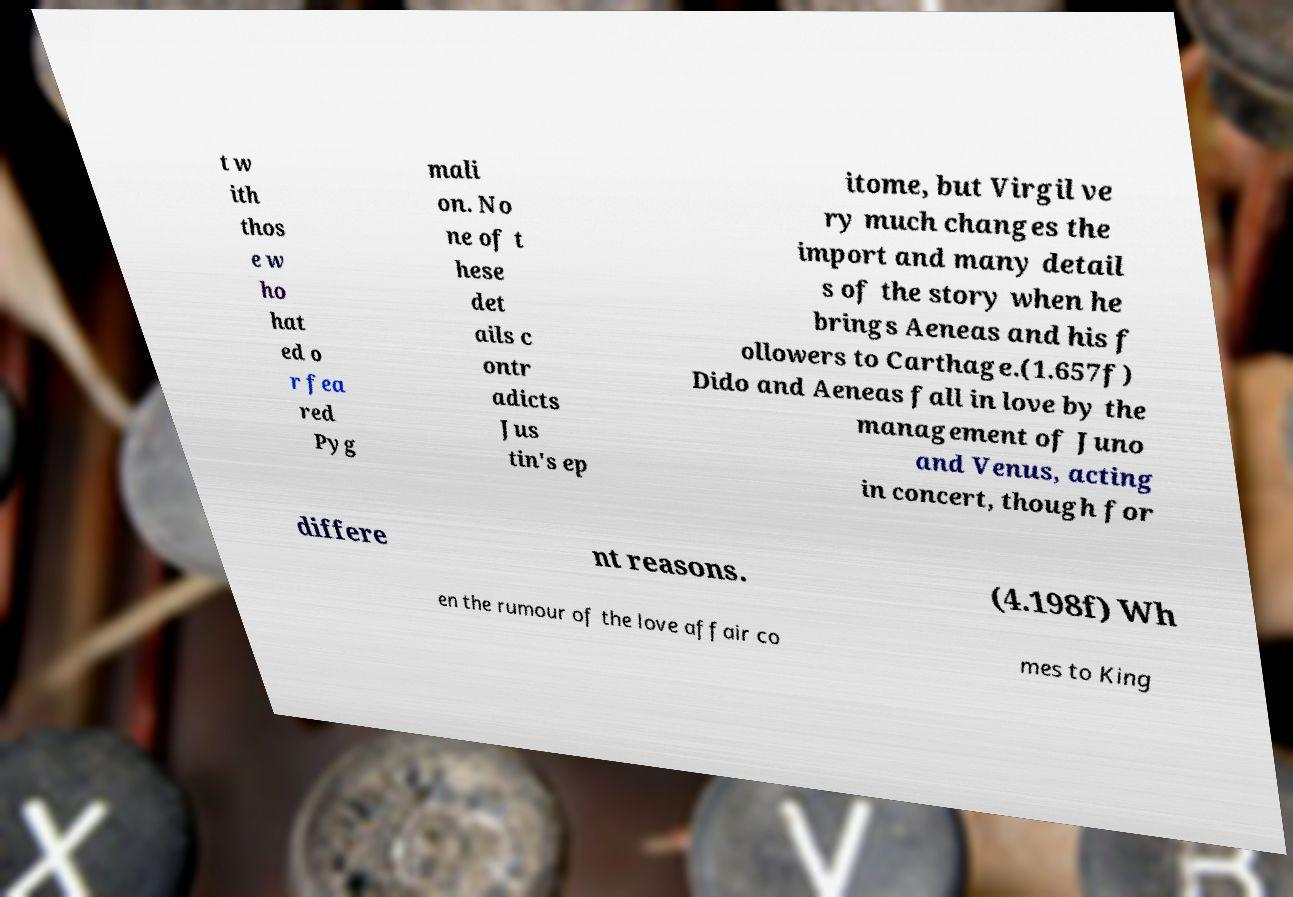Please identify and transcribe the text found in this image. t w ith thos e w ho hat ed o r fea red Pyg mali on. No ne of t hese det ails c ontr adicts Jus tin's ep itome, but Virgil ve ry much changes the import and many detail s of the story when he brings Aeneas and his f ollowers to Carthage.(1.657f) Dido and Aeneas fall in love by the management of Juno and Venus, acting in concert, though for differe nt reasons. (4.198f) Wh en the rumour of the love affair co mes to King 